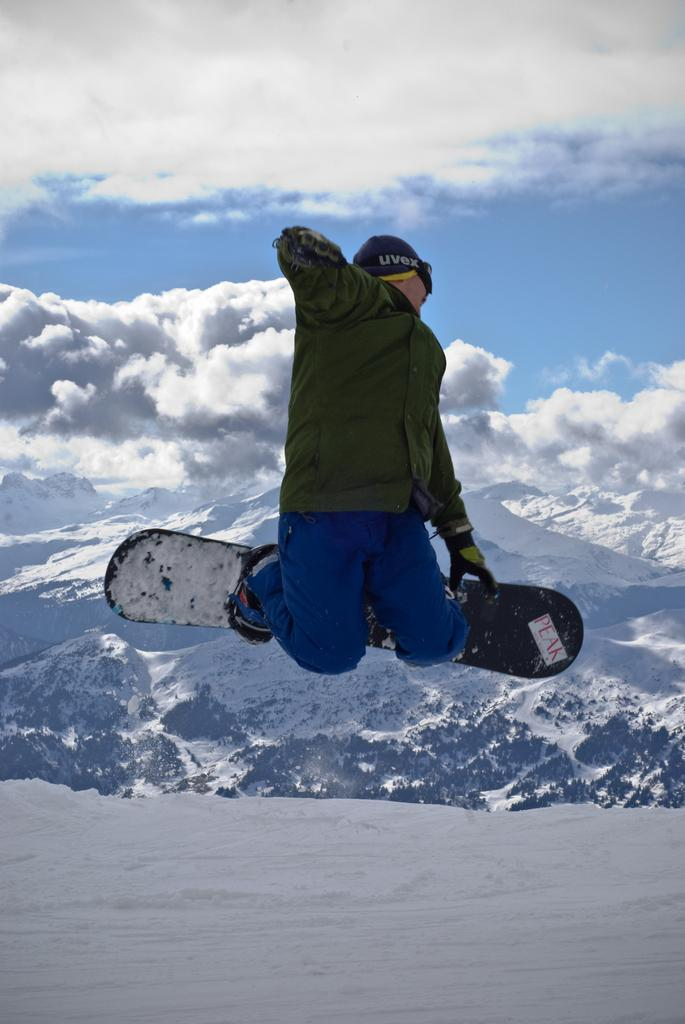Who is the main subject in the image? There is a person in the image. What is the person doing in the image? The person is jumping. What equipment is the person using in the image? The person has ski boards on their legs. What type of terrain is visible in the image? There is snow and mountains in the image. What is the weather like in the image? The sky is cloudy in the image. How many people are in the group that is regretting their decision to ski in the image? There is no group or indication of regret in the image; it only shows a person jumping with ski boards on their legs. 